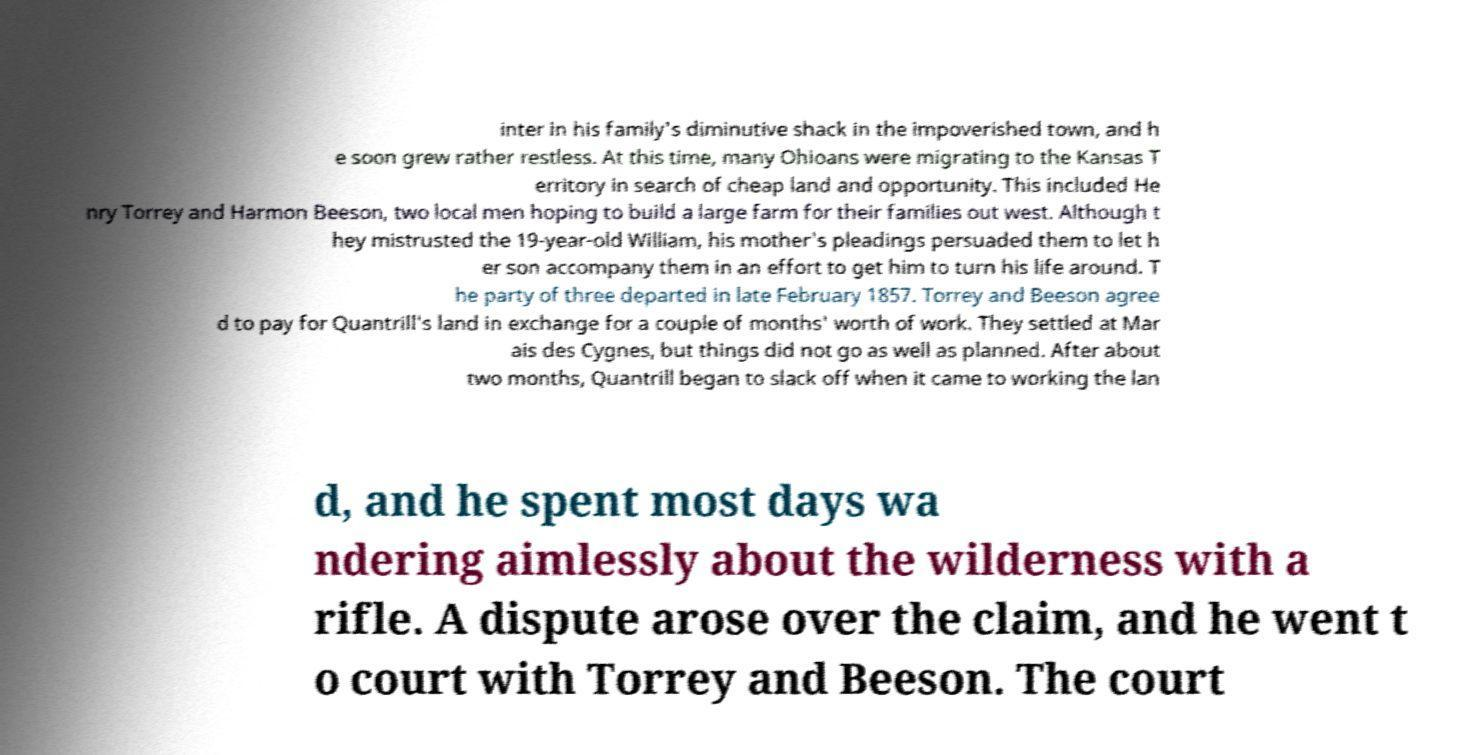Can you accurately transcribe the text from the provided image for me? inter in his family's diminutive shack in the impoverished town, and h e soon grew rather restless. At this time, many Ohioans were migrating to the Kansas T erritory in search of cheap land and opportunity. This included He nry Torrey and Harmon Beeson, two local men hoping to build a large farm for their families out west. Although t hey mistrusted the 19-year-old William, his mother's pleadings persuaded them to let h er son accompany them in an effort to get him to turn his life around. T he party of three departed in late February 1857. Torrey and Beeson agree d to pay for Quantrill's land in exchange for a couple of months' worth of work. They settled at Mar ais des Cygnes, but things did not go as well as planned. After about two months, Quantrill began to slack off when it came to working the lan d, and he spent most days wa ndering aimlessly about the wilderness with a rifle. A dispute arose over the claim, and he went t o court with Torrey and Beeson. The court 